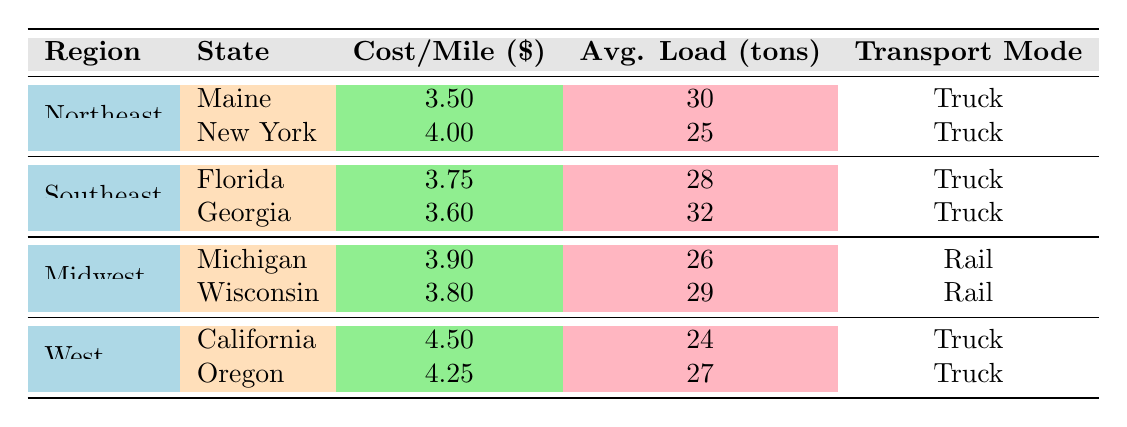What is the cost per mile for transporting timber in Maine? According to the table, in the Northeast region, specifically for Maine, the cost per mile for transporting timber is clearly indicated as 3.50 dollars.
Answer: 3.50 Which state has the highest cost per mile for timber transportation? Looking at the cost per mile values across all states, California has the highest cost at 4.50 dollars per mile.
Answer: California What is the average load weight for timber transport in the Southeast region? To find the average load weight, we take the average of the load weights for Florida (28 tons) and Georgia (32 tons). The calculation is (28 + 32) / 2 = 30 tons.
Answer: 30 Is the transport mode for timber in Wisconsin by rail? The table explicitly states that Wisconsin's transport mode is "Rail." Therefore, the answer is yes.
Answer: Yes In the Midwest region, what is the difference in cost per mile between Michigan and Wisconsin? To find the difference, we subtract the cost per mile for Wisconsin (3.80) from Michigan (3.90): 3.90 - 3.80 = 0.10 dollars.
Answer: 0.10 What is the total average load weight for all states in the Northeast region? For the Northeast region, we add the average load weights: Maine (30 tons) + New York (25 tons) = 55 tons. Since there are 2 states, we average it: 55 / 2 = 27.5 tons.
Answer: 27.5 Which region has the lowest average cost per mile for transporting timber? First, we calculate the average cost per mile for each region by adding the costs of its states and dividing by the number of states. Northeast: (3.50 + 4.00) / 2 = 3.75, Southeast: (3.75 + 3.60) / 2 = 3.675, Midwest: (3.90 + 3.80) / 2 = 3.85, West: (4.50 + 4.25) / 2 = 4.375. The Southeast has the lowest average cost per mile at approximately 3.675 dollars.
Answer: Southeast Does Georgia use rail as its transport mode for timber? The table identifies Georgia's transport mode as "Truck," so the answer is no.
Answer: No 